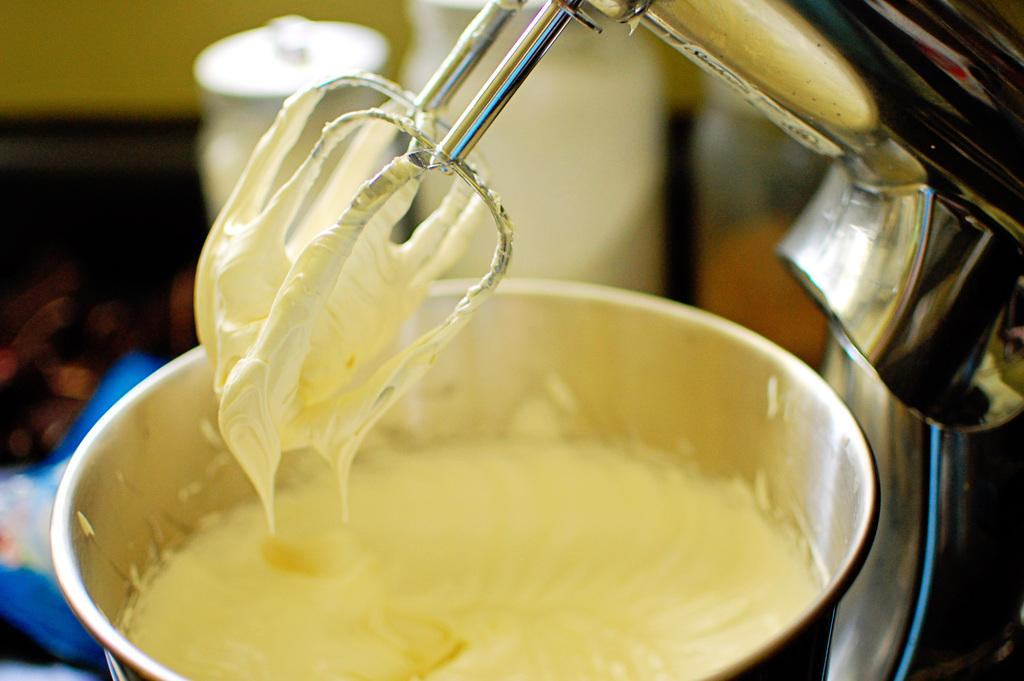What type of appliance is visible in the image? There is a blender machine in the image. What is inside the container in the image? There is a food item in the container in the image. Can you describe the background of the image? The background of the image is blurred. What type of chalk is being used to draw on the blender machine in the image? There is no chalk or drawing present on the blender machine in the image. How many birds are in the flock that is flying over the blender machine in the image? There is no flock or birds present in the image; it only features a blender machine and a container with a food item. 